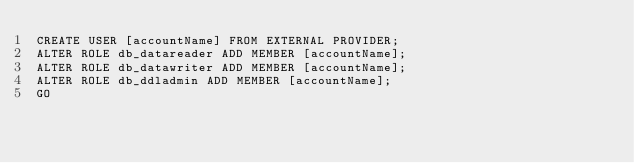<code> <loc_0><loc_0><loc_500><loc_500><_SQL_>CREATE USER [accountName] FROM EXTERNAL PROVIDER;
ALTER ROLE db_datareader ADD MEMBER [accountName];
ALTER ROLE db_datawriter ADD MEMBER [accountName];
ALTER ROLE db_ddladmin ADD MEMBER [accountName];
GO</code> 